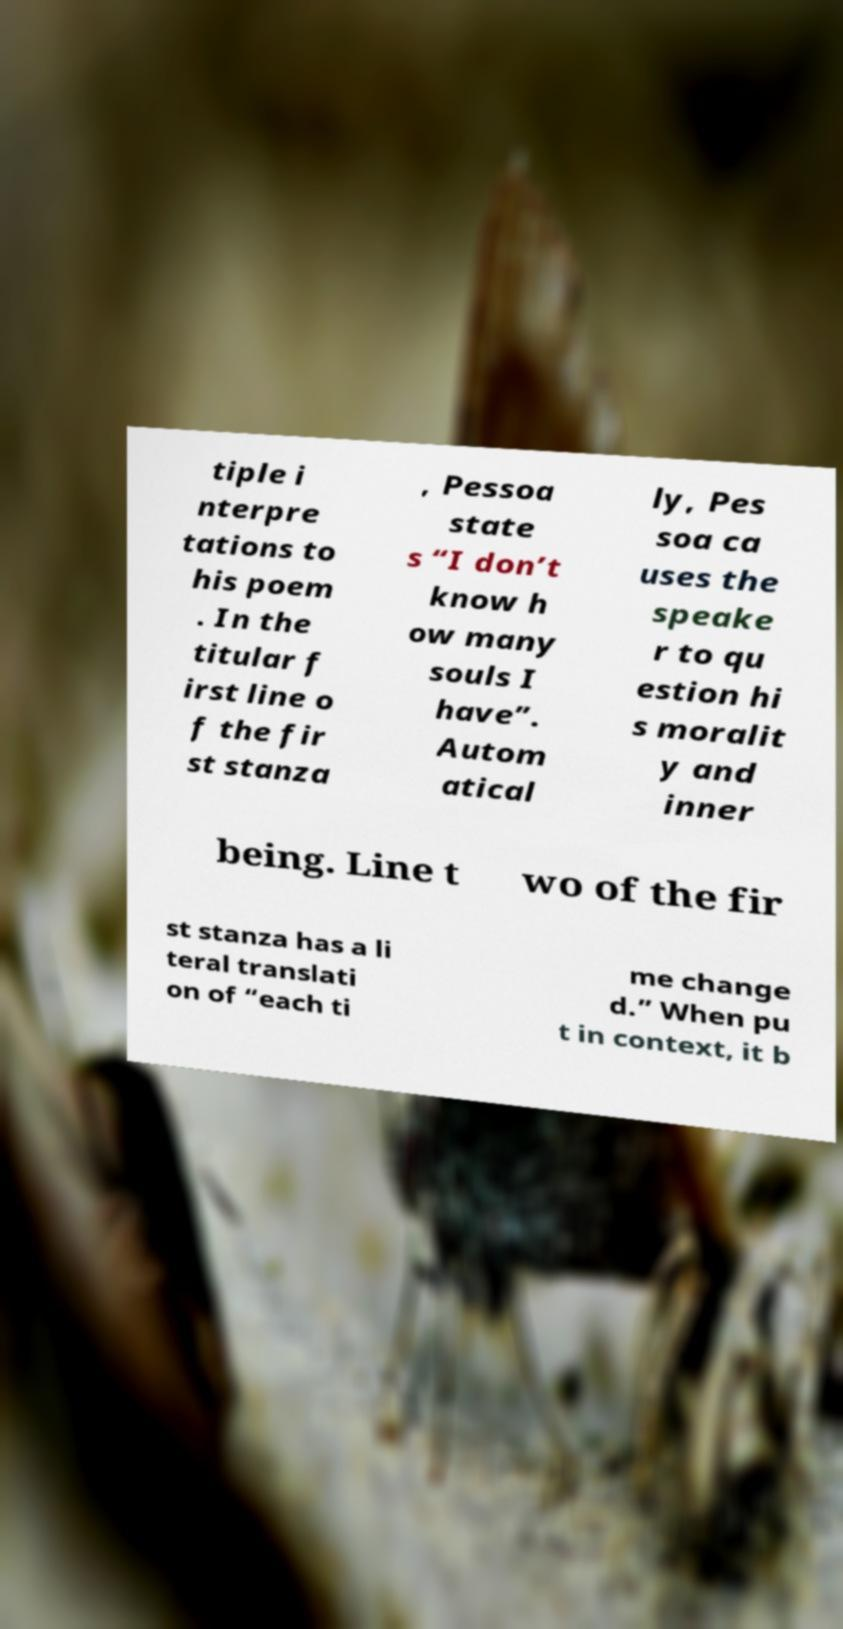Please identify and transcribe the text found in this image. tiple i nterpre tations to his poem . In the titular f irst line o f the fir st stanza , Pessoa state s “I don’t know h ow many souls I have”. Autom atical ly, Pes soa ca uses the speake r to qu estion hi s moralit y and inner being. Line t wo of the fir st stanza has a li teral translati on of “each ti me change d.” When pu t in context, it b 